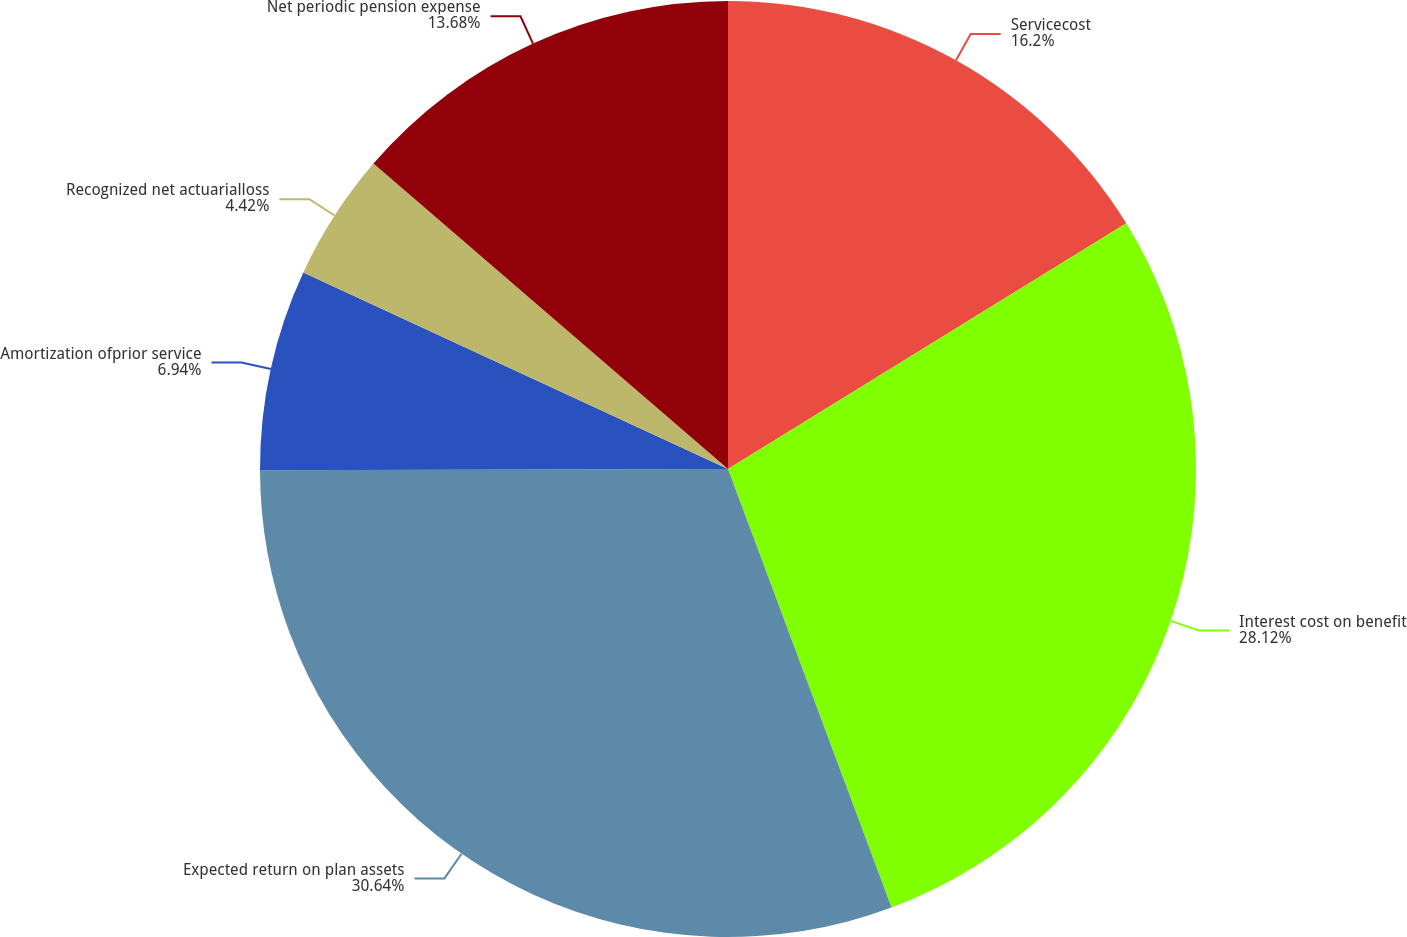<chart> <loc_0><loc_0><loc_500><loc_500><pie_chart><fcel>Servicecost<fcel>Interest cost on benefit<fcel>Expected return on plan assets<fcel>Amortization ofprior service<fcel>Recognized net actuarialloss<fcel>Net periodic pension expense<nl><fcel>16.2%<fcel>28.12%<fcel>30.64%<fcel>6.94%<fcel>4.42%<fcel>13.68%<nl></chart> 